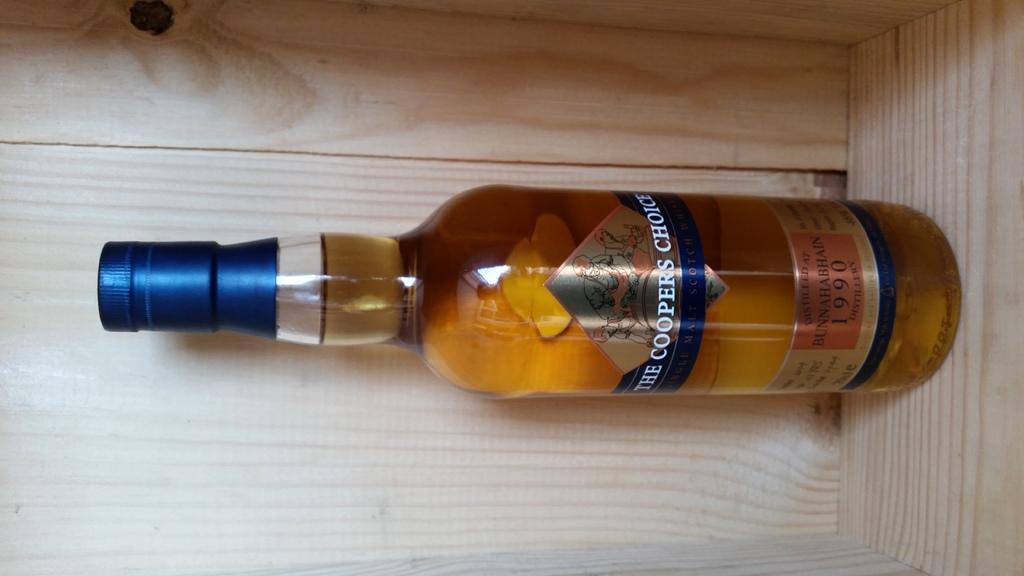Please provide a concise description of this image. In this picture we can see a bottle with full of drink in it. 